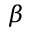<formula> <loc_0><loc_0><loc_500><loc_500>\beta</formula> 